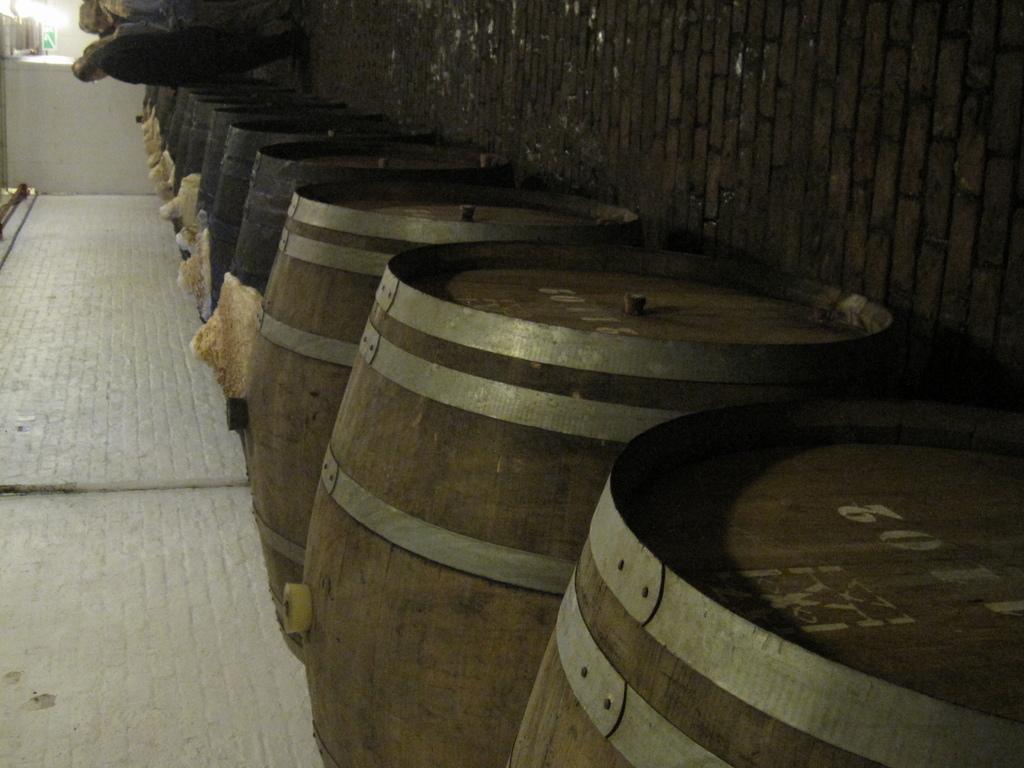What are the serial numbers of these kegs?
Give a very brief answer. 1102. 